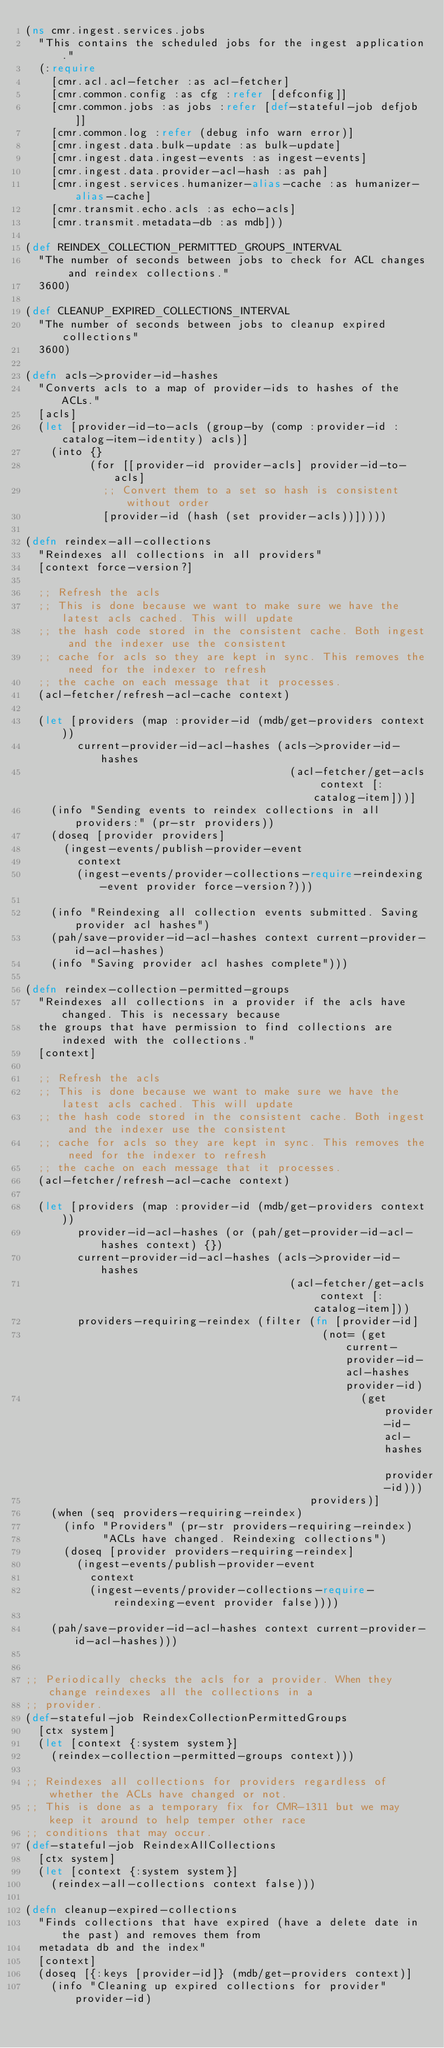<code> <loc_0><loc_0><loc_500><loc_500><_Clojure_>(ns cmr.ingest.services.jobs
  "This contains the scheduled jobs for the ingest application."
  (:require
    [cmr.acl.acl-fetcher :as acl-fetcher]
    [cmr.common.config :as cfg :refer [defconfig]]
    [cmr.common.jobs :as jobs :refer [def-stateful-job defjob]]
    [cmr.common.log :refer (debug info warn error)]
    [cmr.ingest.data.bulk-update :as bulk-update]
    [cmr.ingest.data.ingest-events :as ingest-events]
    [cmr.ingest.data.provider-acl-hash :as pah]
    [cmr.ingest.services.humanizer-alias-cache :as humanizer-alias-cache]
    [cmr.transmit.echo.acls :as echo-acls]
    [cmr.transmit.metadata-db :as mdb]))

(def REINDEX_COLLECTION_PERMITTED_GROUPS_INTERVAL
  "The number of seconds between jobs to check for ACL changes and reindex collections."
  3600)

(def CLEANUP_EXPIRED_COLLECTIONS_INTERVAL
  "The number of seconds between jobs to cleanup expired collections"
  3600)

(defn acls->provider-id-hashes
  "Converts acls to a map of provider-ids to hashes of the ACLs."
  [acls]
  (let [provider-id-to-acls (group-by (comp :provider-id :catalog-item-identity) acls)]
    (into {}
          (for [[provider-id provider-acls] provider-id-to-acls]
            ;; Convert them to a set so hash is consistent without order
            [provider-id (hash (set provider-acls))]))))

(defn reindex-all-collections
  "Reindexes all collections in all providers"
  [context force-version?]

  ;; Refresh the acls
  ;; This is done because we want to make sure we have the latest acls cached. This will update
  ;; the hash code stored in the consistent cache. Both ingest and the indexer use the consistent
  ;; cache for acls so they are kept in sync. This removes the need for the indexer to refresh
  ;; the cache on each message that it processes.
  (acl-fetcher/refresh-acl-cache context)

  (let [providers (map :provider-id (mdb/get-providers context))
        current-provider-id-acl-hashes (acls->provider-id-hashes
                                         (acl-fetcher/get-acls context [:catalog-item]))]
    (info "Sending events to reindex collections in all providers:" (pr-str providers))
    (doseq [provider providers]
      (ingest-events/publish-provider-event
        context
        (ingest-events/provider-collections-require-reindexing-event provider force-version?)))

    (info "Reindexing all collection events submitted. Saving provider acl hashes")
    (pah/save-provider-id-acl-hashes context current-provider-id-acl-hashes)
    (info "Saving provider acl hashes complete")))

(defn reindex-collection-permitted-groups
  "Reindexes all collections in a provider if the acls have changed. This is necessary because
  the groups that have permission to find collections are indexed with the collections."
  [context]

  ;; Refresh the acls
  ;; This is done because we want to make sure we have the latest acls cached. This will update
  ;; the hash code stored in the consistent cache. Both ingest and the indexer use the consistent
  ;; cache for acls so they are kept in sync. This removes the need for the indexer to refresh
  ;; the cache on each message that it processes.
  (acl-fetcher/refresh-acl-cache context)

  (let [providers (map :provider-id (mdb/get-providers context))
        provider-id-acl-hashes (or (pah/get-provider-id-acl-hashes context) {})
        current-provider-id-acl-hashes (acls->provider-id-hashes
                                         (acl-fetcher/get-acls context [:catalog-item]))
        providers-requiring-reindex (filter (fn [provider-id]
                                              (not= (get current-provider-id-acl-hashes provider-id)
                                                    (get provider-id-acl-hashes provider-id)))
                                            providers)]
    (when (seq providers-requiring-reindex)
      (info "Providers" (pr-str providers-requiring-reindex)
            "ACLs have changed. Reindexing collections")
      (doseq [provider providers-requiring-reindex]
        (ingest-events/publish-provider-event
          context
          (ingest-events/provider-collections-require-reindexing-event provider false))))

    (pah/save-provider-id-acl-hashes context current-provider-id-acl-hashes)))


;; Periodically checks the acls for a provider. When they change reindexes all the collections in a
;; provider.
(def-stateful-job ReindexCollectionPermittedGroups
  [ctx system]
  (let [context {:system system}]
    (reindex-collection-permitted-groups context)))

;; Reindexes all collections for providers regardless of whether the ACLs have changed or not.
;; This is done as a temporary fix for CMR-1311 but we may keep it around to help temper other race
;; conditions that may occur.
(def-stateful-job ReindexAllCollections
  [ctx system]
  (let [context {:system system}]
    (reindex-all-collections context false)))

(defn cleanup-expired-collections
  "Finds collections that have expired (have a delete date in the past) and removes them from
  metadata db and the index"
  [context]
  (doseq [{:keys [provider-id]} (mdb/get-providers context)]
    (info "Cleaning up expired collections for provider" provider-id)</code> 